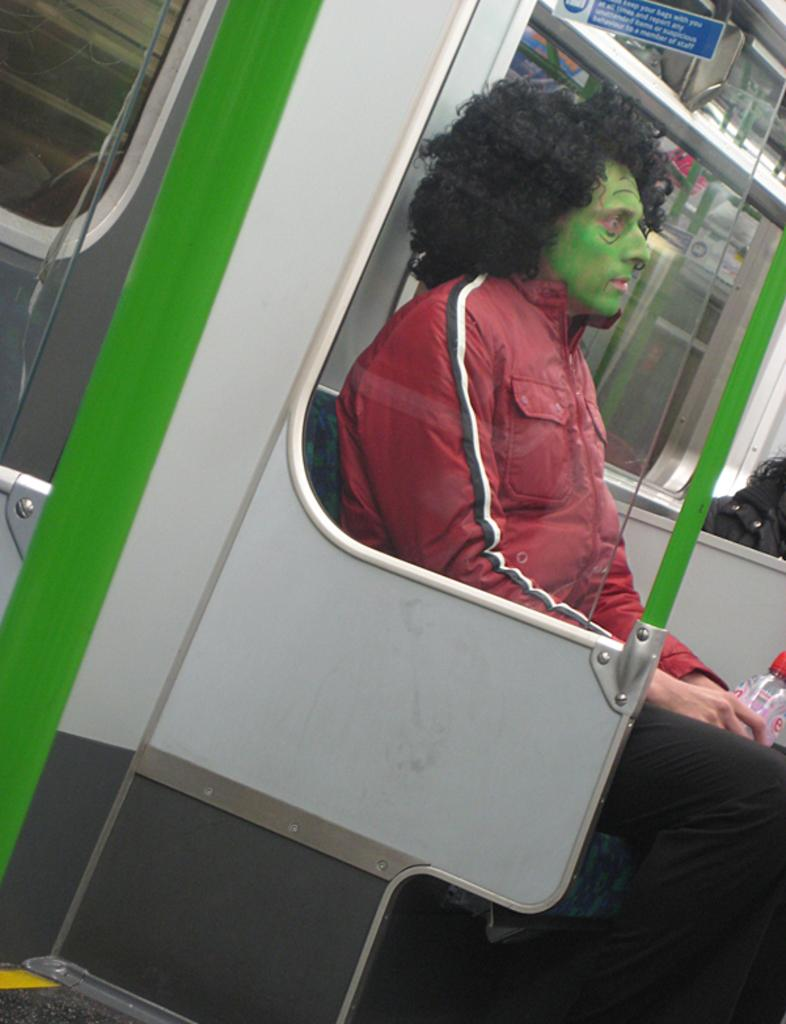What is the person in the image doing? The person is sitting in a metro train. Where is the person located in the image? The person is on the right side of the image. What is the person holding in the image? The person is holding a bottle. What type of leather material is covering the person's mitten in the image? There is no mitten or leather material present in the image. 